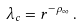Convert formula to latex. <formula><loc_0><loc_0><loc_500><loc_500>\lambda _ { c } = r ^ { - \rho _ { \infty } } \, .</formula> 